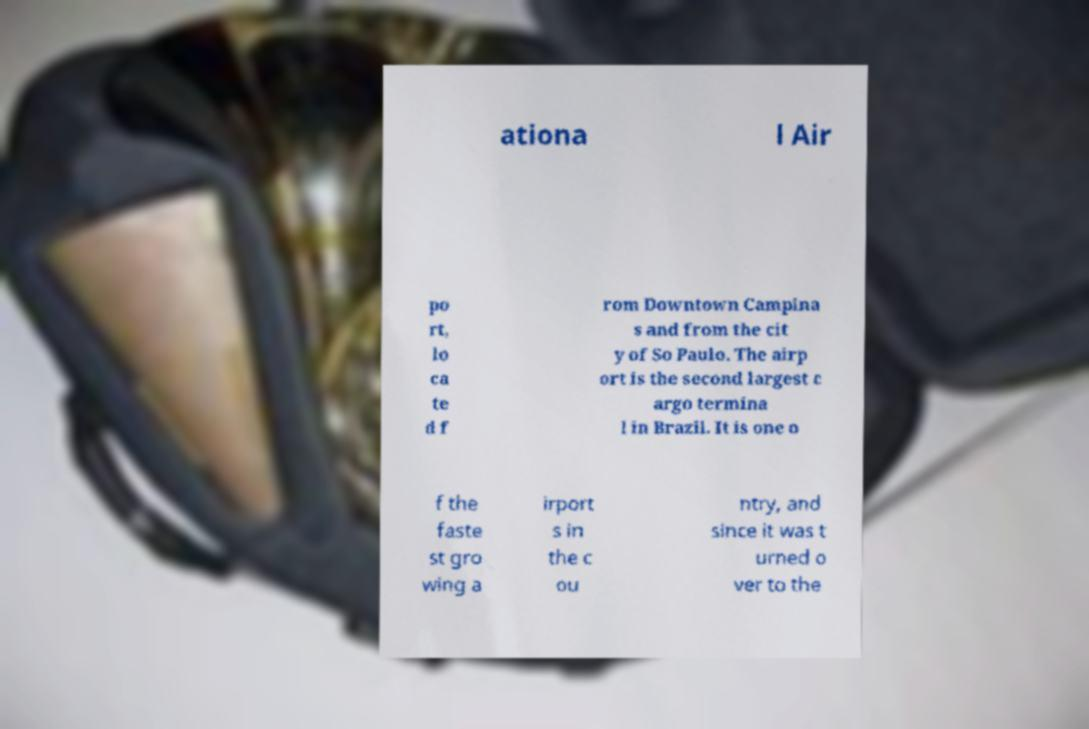Could you assist in decoding the text presented in this image and type it out clearly? ationa l Air po rt, lo ca te d f rom Downtown Campina s and from the cit y of So Paulo. The airp ort is the second largest c argo termina l in Brazil. It is one o f the faste st gro wing a irport s in the c ou ntry, and since it was t urned o ver to the 